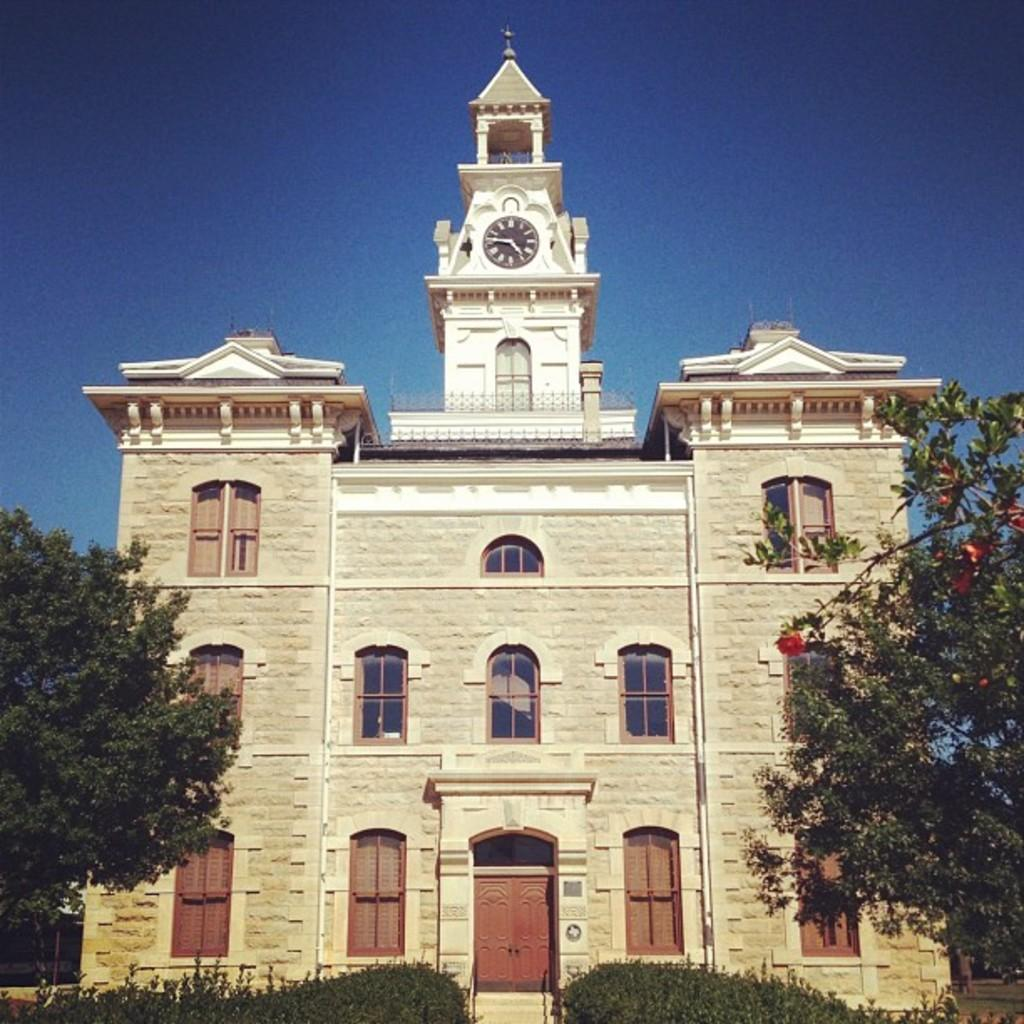What is the main structure in the middle of the image? There is a building in the middle of the image. What type of vegetation can be seen in the image? There are trees, shrubs, and flowers in the image. Can you describe any specific features on the building? There is a clock on the building. What color is the tendency in the image? There is no mention of a "tendency" in the image, so it is not possible to determine its color. 